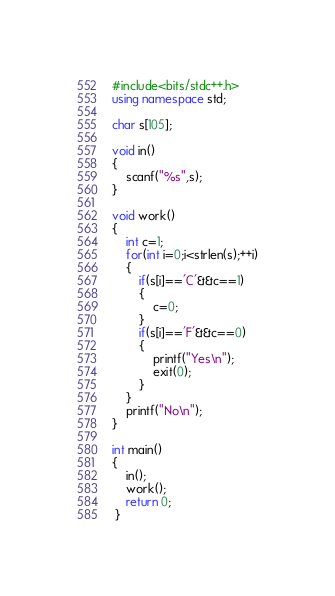Convert code to text. <code><loc_0><loc_0><loc_500><loc_500><_C++_>#include<bits/stdc++.h>
using namespace std;

char s[105];

void in()
{
    scanf("%s",s);
}

void work()
{
    int c=1;
    for(int i=0;i<strlen(s);++i)
    {
        if(s[i]=='C'&&c==1)
        {
            c=0;
        }
        if(s[i]=='F'&&c==0)
        {
            printf("Yes\n");
            exit(0);
        }
    }
    printf("No\n");
}

int main()
{
    in();
    work();
    return 0;
 }</code> 